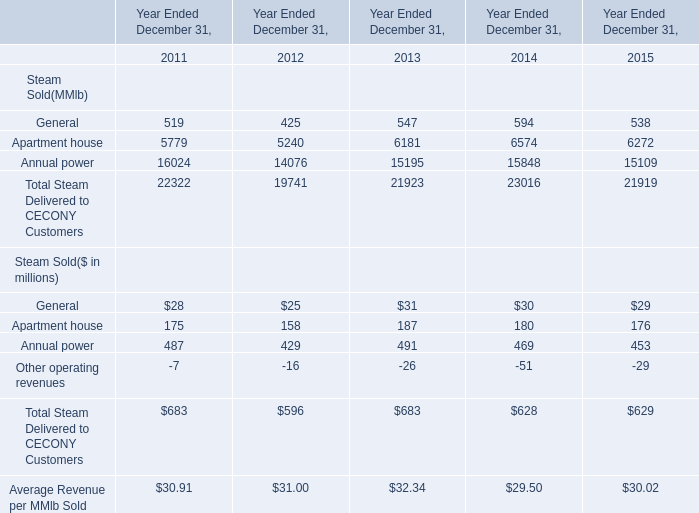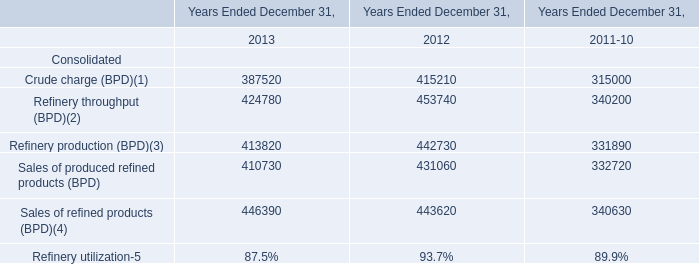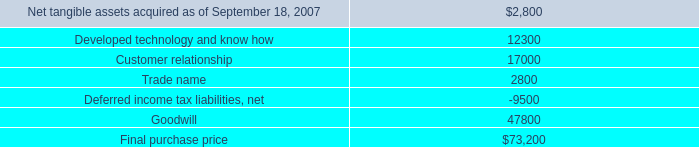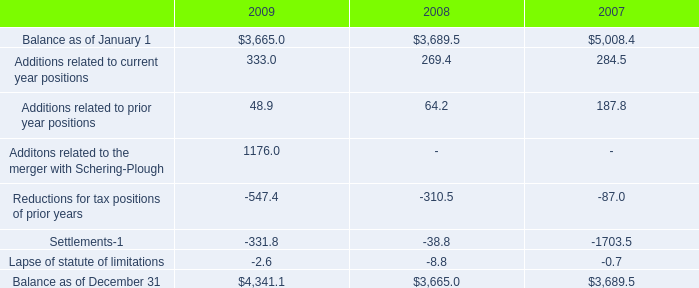What's the average of the General for Steam Sold($ in millions) in the years where Refinery production (BPD)(3) for Consolidated is positive? (in million) 
Computations: (((28 + 25) + 31) / 3)
Answer: 28.0. 